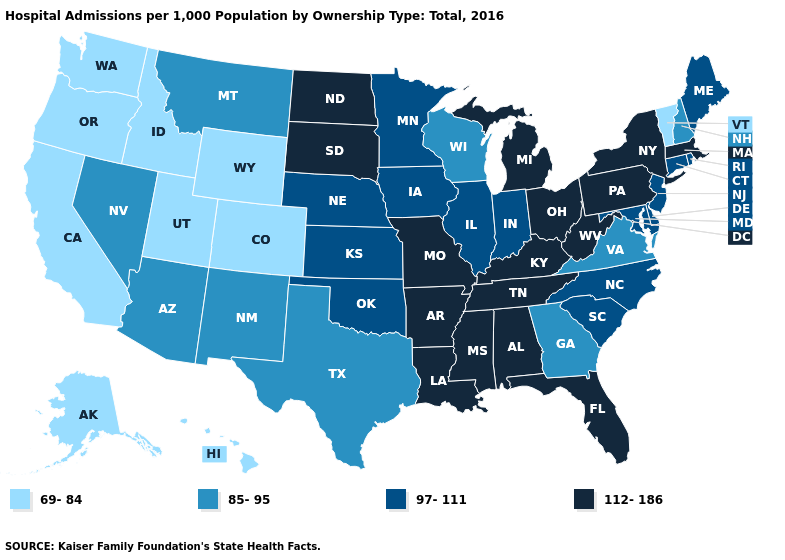What is the lowest value in the USA?
Give a very brief answer. 69-84. What is the value of Nebraska?
Write a very short answer. 97-111. Is the legend a continuous bar?
Answer briefly. No. Does Hawaii have the lowest value in the USA?
Give a very brief answer. Yes. Among the states that border Connecticut , which have the highest value?
Keep it brief. Massachusetts, New York. Name the states that have a value in the range 97-111?
Short answer required. Connecticut, Delaware, Illinois, Indiana, Iowa, Kansas, Maine, Maryland, Minnesota, Nebraska, New Jersey, North Carolina, Oklahoma, Rhode Island, South Carolina. Does Mississippi have a lower value than California?
Quick response, please. No. Which states have the lowest value in the Northeast?
Keep it brief. Vermont. Which states have the highest value in the USA?
Short answer required. Alabama, Arkansas, Florida, Kentucky, Louisiana, Massachusetts, Michigan, Mississippi, Missouri, New York, North Dakota, Ohio, Pennsylvania, South Dakota, Tennessee, West Virginia. Which states have the highest value in the USA?
Short answer required. Alabama, Arkansas, Florida, Kentucky, Louisiana, Massachusetts, Michigan, Mississippi, Missouri, New York, North Dakota, Ohio, Pennsylvania, South Dakota, Tennessee, West Virginia. What is the highest value in the South ?
Be succinct. 112-186. Does Hawaii have the same value as Oregon?
Short answer required. Yes. Does West Virginia have a higher value than Massachusetts?
Be succinct. No. What is the value of South Carolina?
Keep it brief. 97-111. What is the highest value in states that border Mississippi?
Give a very brief answer. 112-186. 